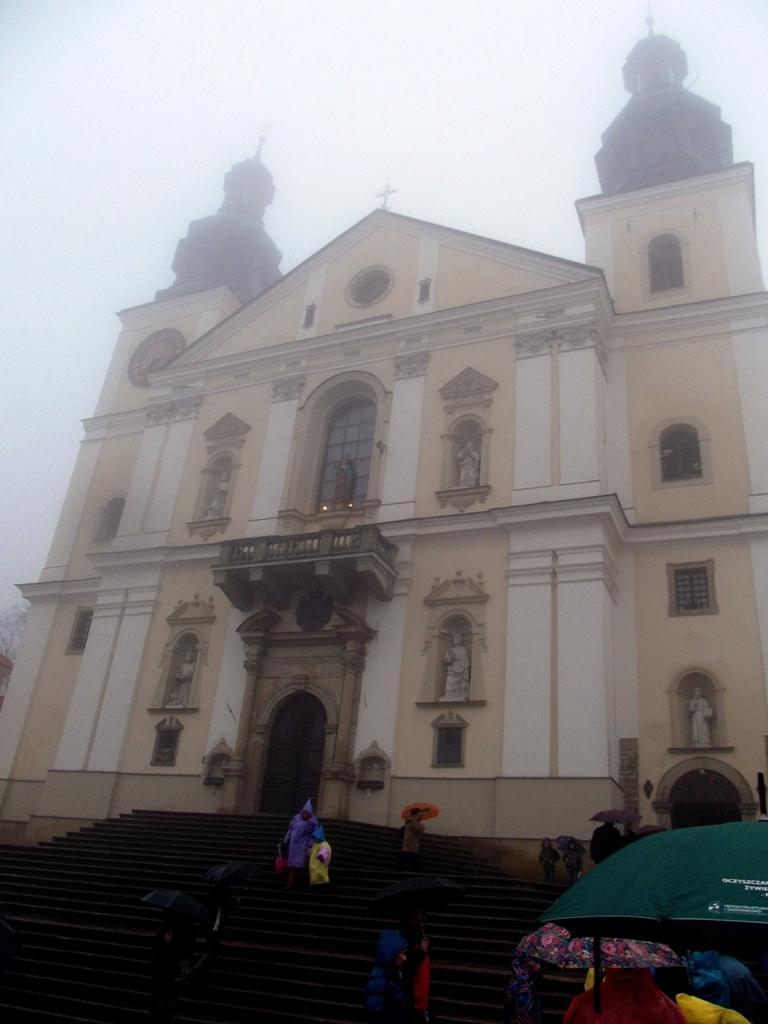In one or two sentences, can you explain what this image depicts? In this image I can see there is a building, it has few windows, stairs, there are few people wearing raincoats, carrying umbrellas and the sky is foggy. 